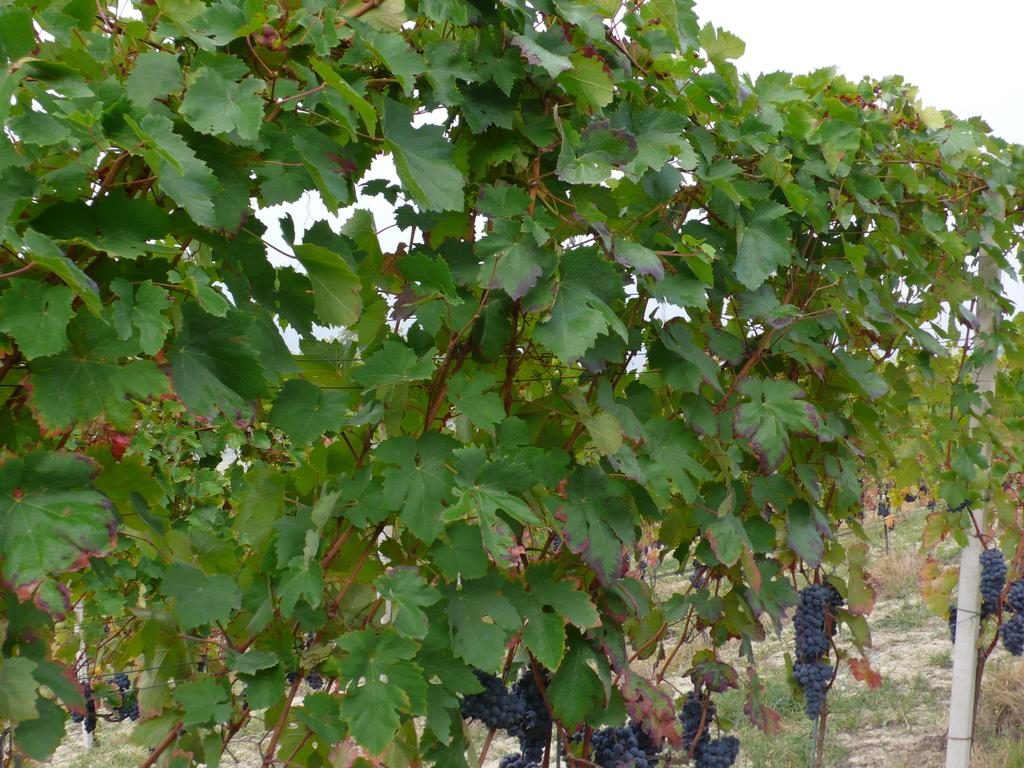What is the main subject of the image? There is a grape vine in the center of the image. Can you describe the grape vine in more detail? The grape vine appears to have leaves and possibly grapes. Is there anything else in the image besides the grape vine? The provided facts do not mention any other subjects in the image. How does the girl slide down the slope in the image? There is no girl or slope present in the image; it only features a grape vine. 